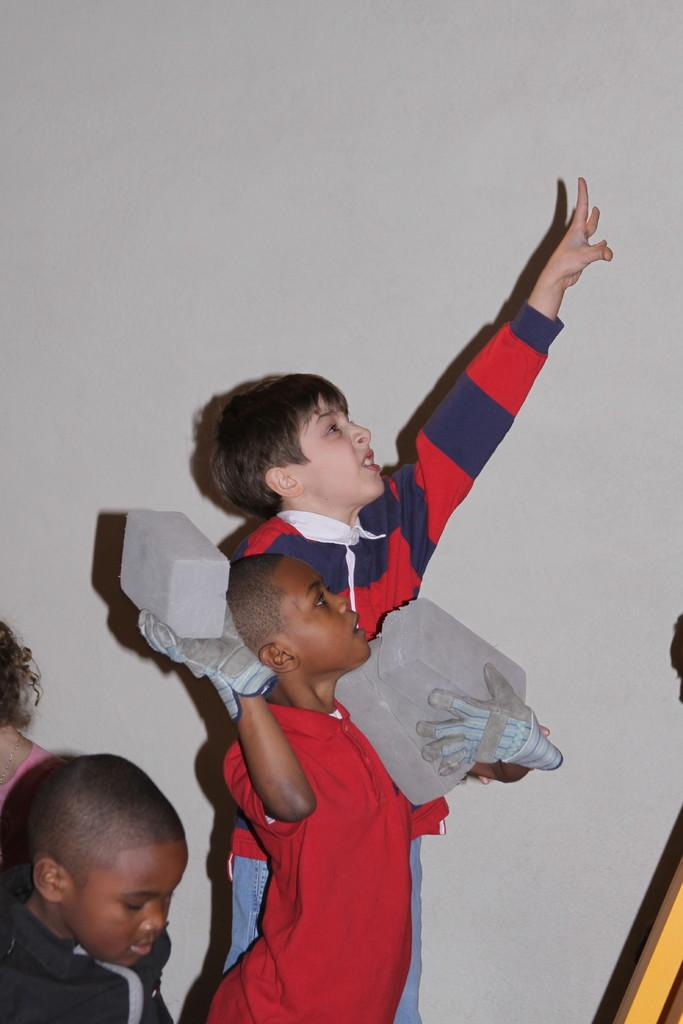What is the main subject of the image? The main subject of the image is a group of children. Can you describe the actions of the children in the image? One child has raised their hand, and another child is holding bricks. What type of wound can be seen on the child holding bricks in the image? There is no wound visible on the child holding bricks in the image. Is there a spy present in the image? There is no mention of a spy in the image, and no such figure is visible. 